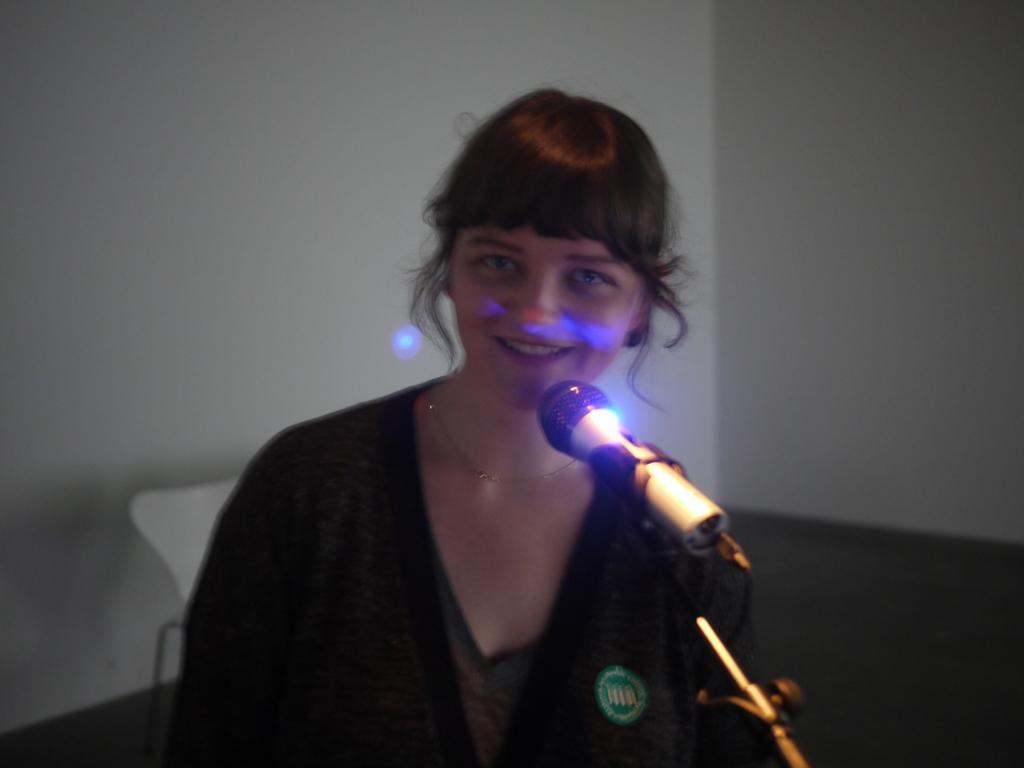How would you summarize this image in a sentence or two? In this image, we can see a person. We can see a microphone and the ground. We can also see the wall and a white colored object. 